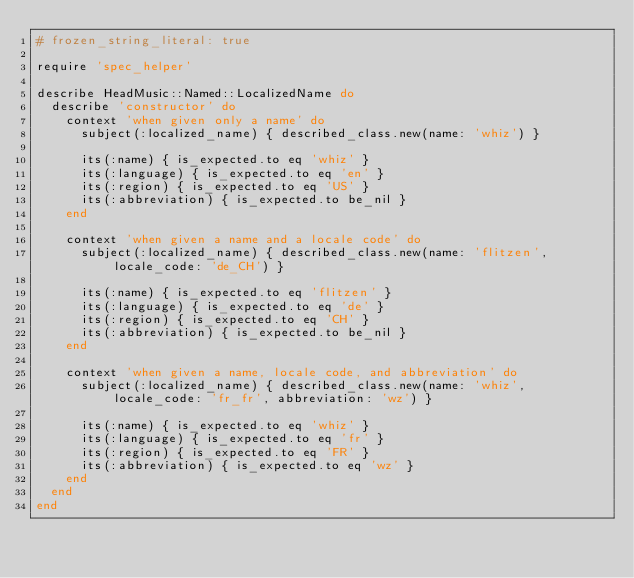<code> <loc_0><loc_0><loc_500><loc_500><_Ruby_># frozen_string_literal: true

require 'spec_helper'

describe HeadMusic::Named::LocalizedName do
  describe 'constructor' do
    context 'when given only a name' do
      subject(:localized_name) { described_class.new(name: 'whiz') }

      its(:name) { is_expected.to eq 'whiz' }
      its(:language) { is_expected.to eq 'en' }
      its(:region) { is_expected.to eq 'US' }
      its(:abbreviation) { is_expected.to be_nil }
    end

    context 'when given a name and a locale code' do
      subject(:localized_name) { described_class.new(name: 'flitzen', locale_code: 'de_CH') }

      its(:name) { is_expected.to eq 'flitzen' }
      its(:language) { is_expected.to eq 'de' }
      its(:region) { is_expected.to eq 'CH' }
      its(:abbreviation) { is_expected.to be_nil }
    end

    context 'when given a name, locale code, and abbreviation' do
      subject(:localized_name) { described_class.new(name: 'whiz', locale_code: 'fr_fr', abbreviation: 'wz') }

      its(:name) { is_expected.to eq 'whiz' }
      its(:language) { is_expected.to eq 'fr' }
      its(:region) { is_expected.to eq 'FR' }
      its(:abbreviation) { is_expected.to eq 'wz' }
    end
  end
end
</code> 